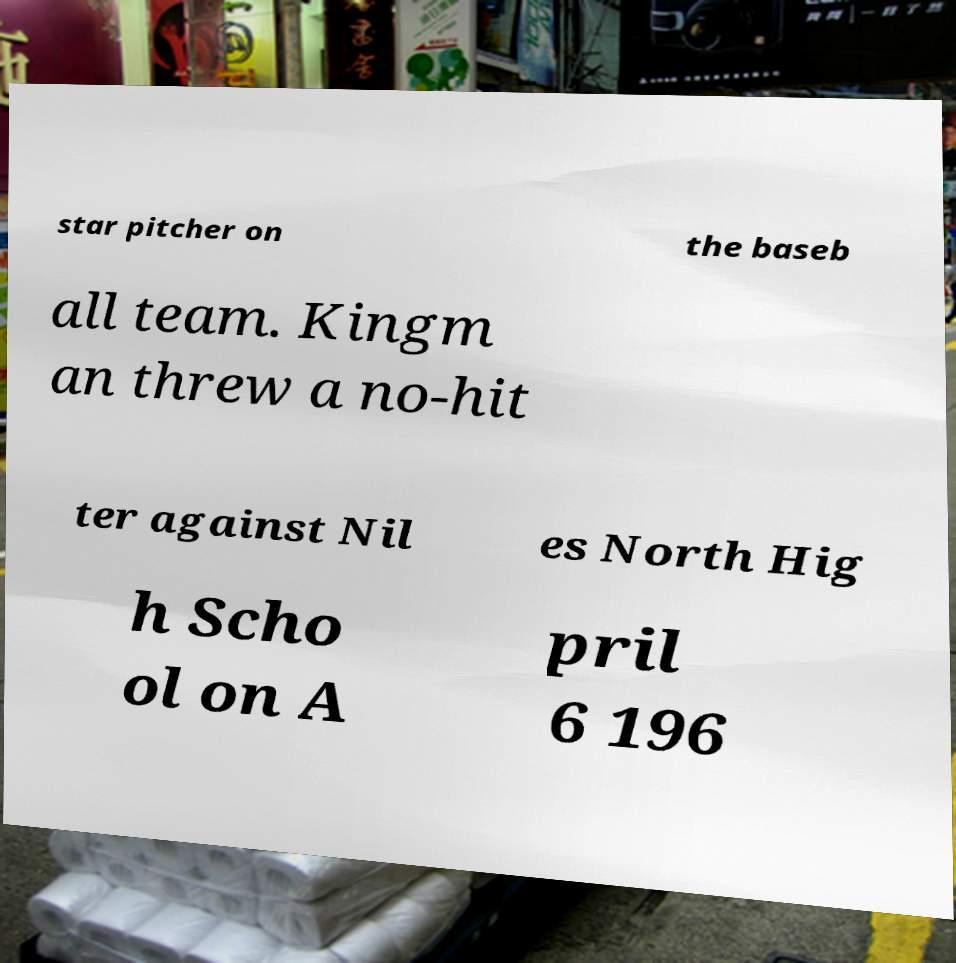There's text embedded in this image that I need extracted. Can you transcribe it verbatim? star pitcher on the baseb all team. Kingm an threw a no-hit ter against Nil es North Hig h Scho ol on A pril 6 196 